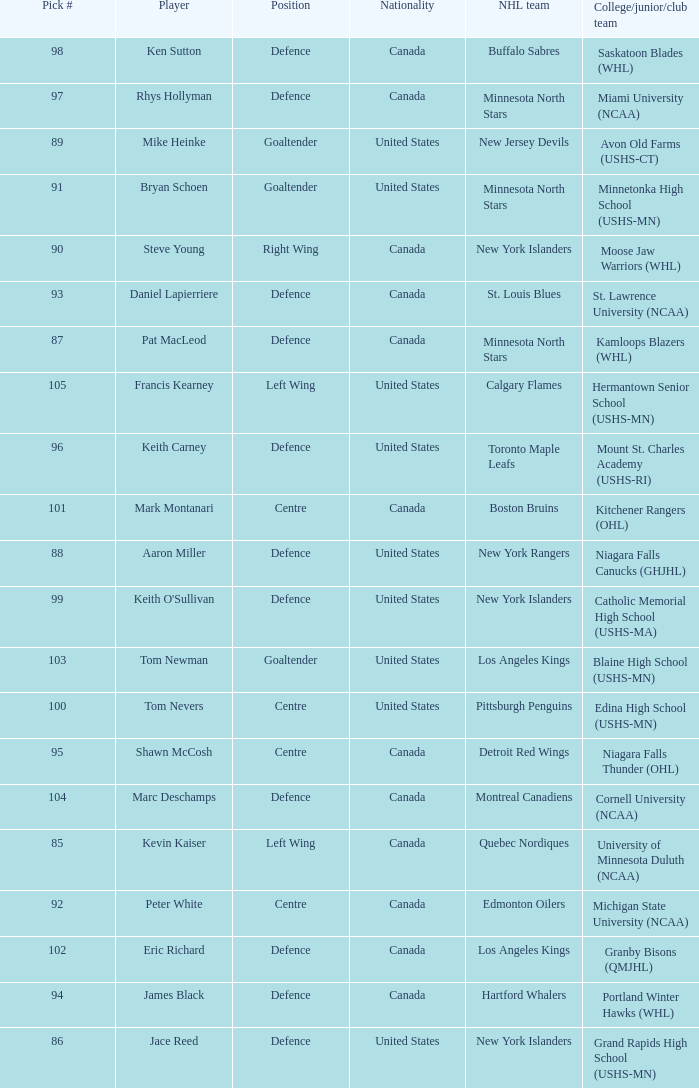What nationality is keith carney? United States. 